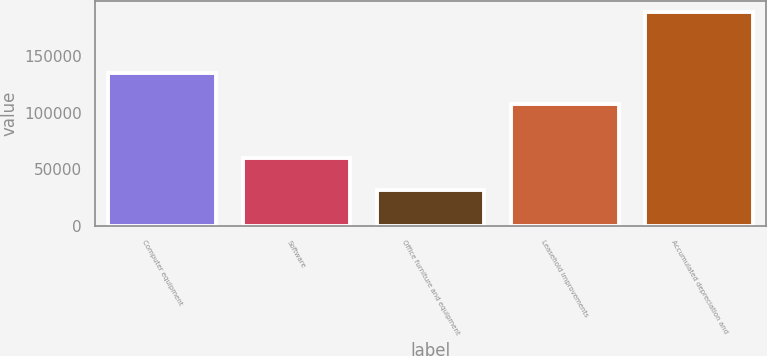<chart> <loc_0><loc_0><loc_500><loc_500><bar_chart><fcel>Computer equipment<fcel>Software<fcel>Office furniture and equipment<fcel>Leasehold improvements<fcel>Accumulated depreciation and<nl><fcel>135176<fcel>59671<fcel>31625<fcel>107615<fcel>189045<nl></chart> 